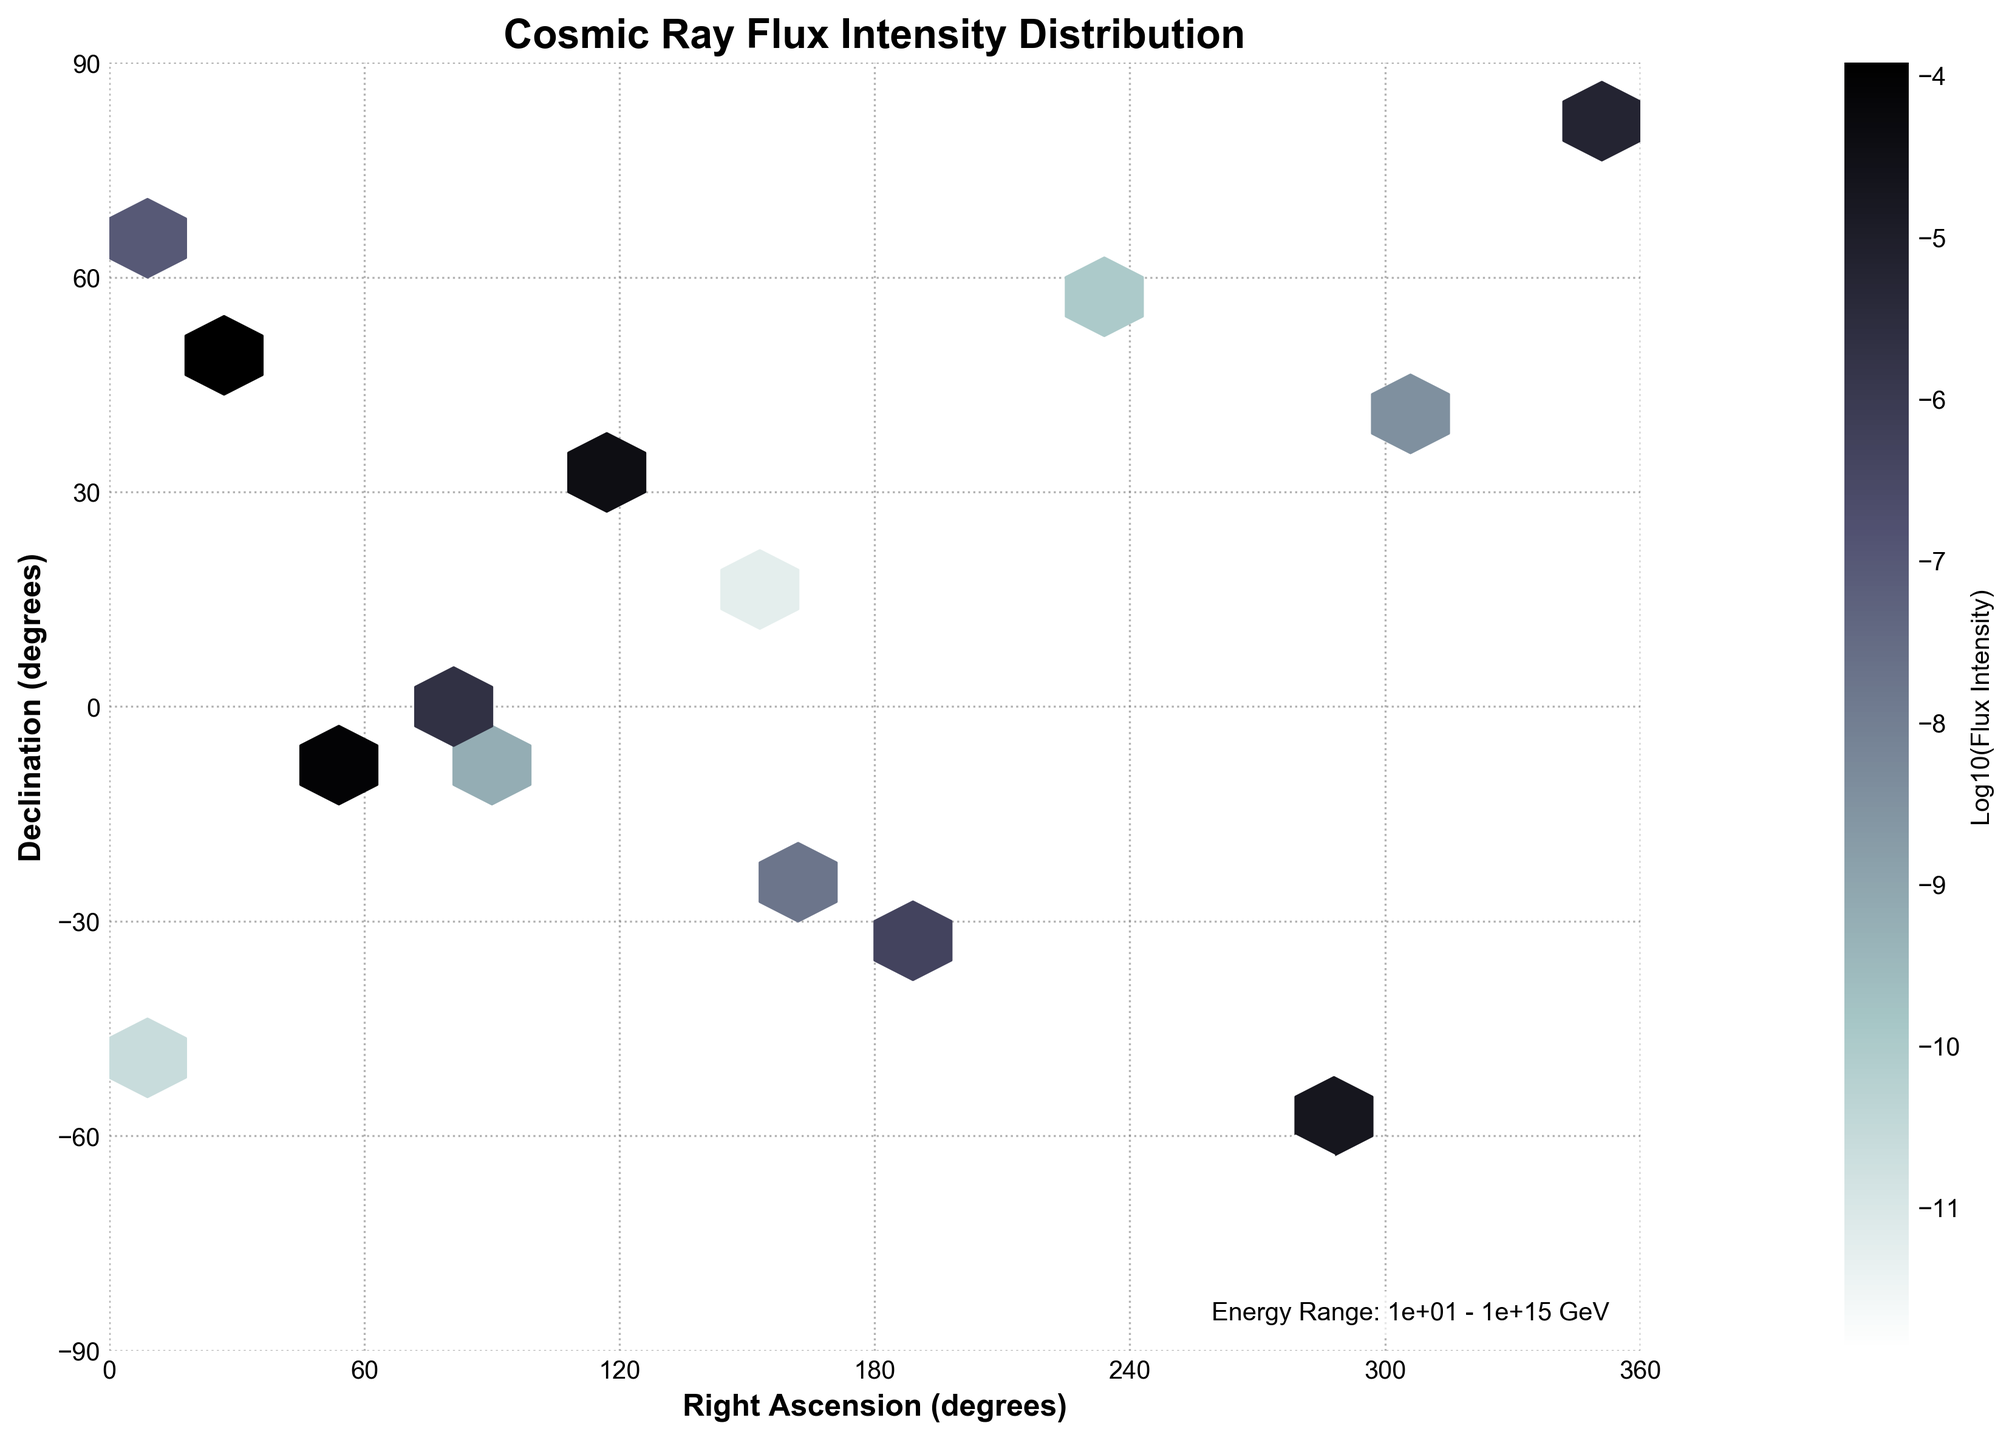What is the title of the Hexbin Plot? The title is located at the top of the plot.
Answer: Cosmic Ray Flux Intensity Distribution What are the labels of the x-axis and y-axis? The x-axis label is at the bottom of the plot and the y-axis label is at the left side of the plot.
Answer: Right Ascension (degrees), Declination (degrees) What color scale is used to represent the flux intensity? The color scale is provided by a color bar on the right side of the plot. The colors range from dark gray to white, indicating different levels of intensity.
Answer: Grayscale ranging from dark gray to white Which region has the highest observed flux intensity in terms of Right Ascension and Declination? The region with the highest intensity corresponds to the brightest white spots on the plot. Look for the coordinates near the brightest regions.
Answer: Around Right Ascension 23.5 degrees and Declination 45.2 degrees What's the RA range covered in this plot? The range is determined by the x-axis limits.
Answer: 0 to 360 degrees What energy range does the data cover? The energy range is indicated by a text box at the bottom right of the plot.
Answer: \(1 \times 10^1\) GeV to \(1 \times 10^{15}\) GeV In which RA range do you observe the lowest flux intensities? The lowest intensities correspond to the darkest regions on the plot.
Answer: Around Right Ascension 120 to 240 degrees How does the declination affect the flux intensity distribution around RA of 10 degrees? Examine the variation of intensity vertically across different declination values at RA ~ 10 degrees. The intensity varies as you move from the top to bottom.
Answer: High intensity at positive Declination and lower as it moves to negative What is the median flux intensity observed? To find the median, identify the middle value of the color bar legend. Identify the corresponding color and search across the plot for the median color tone.
Answer: The median flux intensity is about \(10^{-6}\) or Log10 value -6 Does the flux intensity vary more with Right Ascension or Declination? To answer this, compare the changes in flux intensities across RA and Dec. Notice how frequently the colors change vertically versus horizontally.
Answer: Declination 